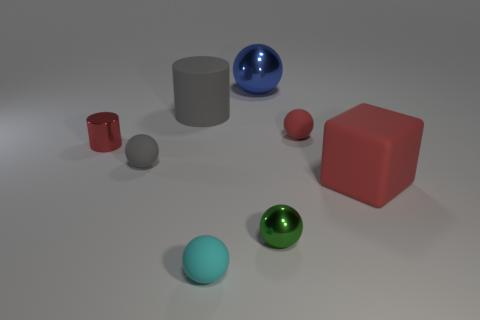There is a gray matte cylinder on the right side of the tiny matte sphere to the left of the gray cylinder; are there any shiny things that are in front of it? In the image, two shiny spheres are present — one blue and one green. The blue shiny sphere is indeed in front of the gray matte cylinder on the right, reflecting light and exhibiting a glossy finish. 